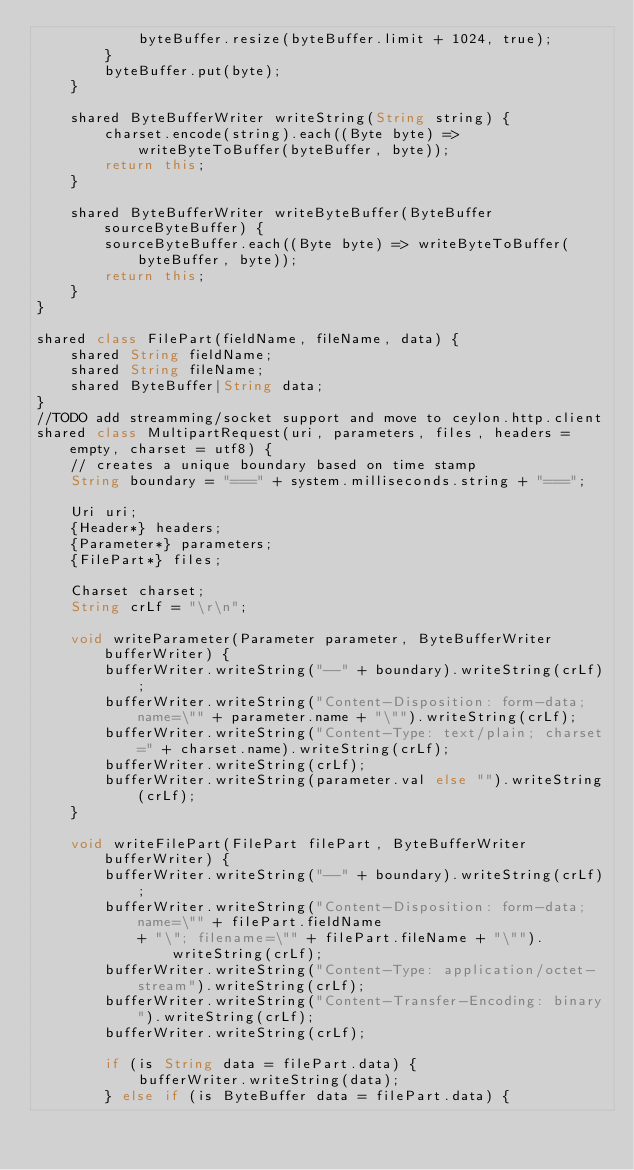<code> <loc_0><loc_0><loc_500><loc_500><_Ceylon_>            byteBuffer.resize(byteBuffer.limit + 1024, true);
        }
        byteBuffer.put(byte);
    }

    shared ByteBufferWriter writeString(String string) {
        charset.encode(string).each((Byte byte) => writeByteToBuffer(byteBuffer, byte)); 
        return this;
    }

    shared ByteBufferWriter writeByteBuffer(ByteBuffer sourceByteBuffer) {
        sourceByteBuffer.each((Byte byte) => writeByteToBuffer(byteBuffer, byte));
        return this;
    }
}

shared class FilePart(fieldName, fileName, data) {
    shared String fieldName;
    shared String fileName;
    shared ByteBuffer|String data;
}
//TODO add streamming/socket support and move to ceylon.http.client
shared class MultipartRequest(uri, parameters, files, headers = empty, charset = utf8) {
    // creates a unique boundary based on time stamp
    String boundary = "===" + system.milliseconds.string + "===";
    
    Uri uri;
    {Header*} headers;
    {Parameter*} parameters;
    {FilePart*} files;

    Charset charset;
    String crLf = "\r\n";
    
    void writeParameter(Parameter parameter, ByteBufferWriter bufferWriter) {
        bufferWriter.writeString("--" + boundary).writeString(crLf);
        bufferWriter.writeString("Content-Disposition: form-data; name=\"" + parameter.name + "\"").writeString(crLf);
        bufferWriter.writeString("Content-Type: text/plain; charset=" + charset.name).writeString(crLf);
        bufferWriter.writeString(crLf);
        bufferWriter.writeString(parameter.val else "").writeString(crLf);
    }
    
    void writeFilePart(FilePart filePart, ByteBufferWriter bufferWriter) {
        bufferWriter.writeString("--" + boundary).writeString(crLf);
        bufferWriter.writeString("Content-Disposition: form-data; name=\"" + filePart.fieldName 
            + "\"; filename=\"" + filePart.fileName + "\"").writeString(crLf);
        bufferWriter.writeString("Content-Type: application/octet-stream").writeString(crLf);
        bufferWriter.writeString("Content-Transfer-Encoding: binary").writeString(crLf);
        bufferWriter.writeString(crLf);
        
        if (is String data = filePart.data) {
            bufferWriter.writeString(data);
        } else if (is ByteBuffer data = filePart.data) {</code> 